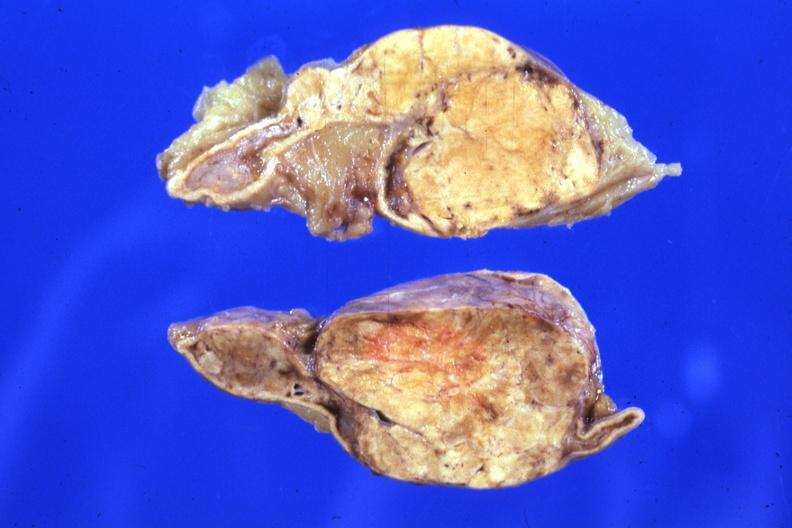does this image show fixed tissue sectioned gland rather large lesion?
Answer the question using a single word or phrase. Yes 